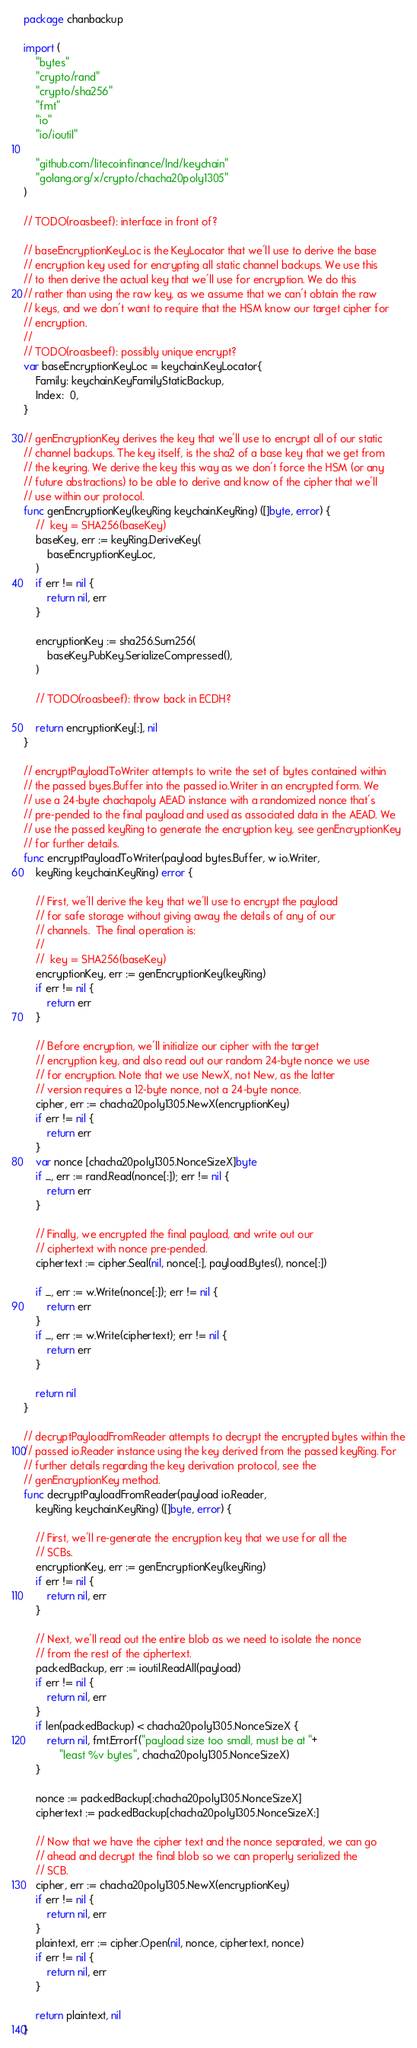<code> <loc_0><loc_0><loc_500><loc_500><_Go_>package chanbackup

import (
	"bytes"
	"crypto/rand"
	"crypto/sha256"
	"fmt"
	"io"
	"io/ioutil"

	"github.com/litecoinfinance/lnd/keychain"
	"golang.org/x/crypto/chacha20poly1305"
)

// TODO(roasbeef): interface in front of?

// baseEncryptionKeyLoc is the KeyLocator that we'll use to derive the base
// encryption key used for encrypting all static channel backups. We use this
// to then derive the actual key that we'll use for encryption. We do this
// rather than using the raw key, as we assume that we can't obtain the raw
// keys, and we don't want to require that the HSM know our target cipher for
// encryption.
//
// TODO(roasbeef): possibly unique encrypt?
var baseEncryptionKeyLoc = keychain.KeyLocator{
	Family: keychain.KeyFamilyStaticBackup,
	Index:  0,
}

// genEncryptionKey derives the key that we'll use to encrypt all of our static
// channel backups. The key itself, is the sha2 of a base key that we get from
// the keyring. We derive the key this way as we don't force the HSM (or any
// future abstractions) to be able to derive and know of the cipher that we'll
// use within our protocol.
func genEncryptionKey(keyRing keychain.KeyRing) ([]byte, error) {
	//  key = SHA256(baseKey)
	baseKey, err := keyRing.DeriveKey(
		baseEncryptionKeyLoc,
	)
	if err != nil {
		return nil, err
	}

	encryptionKey := sha256.Sum256(
		baseKey.PubKey.SerializeCompressed(),
	)

	// TODO(roasbeef): throw back in ECDH?

	return encryptionKey[:], nil
}

// encryptPayloadToWriter attempts to write the set of bytes contained within
// the passed byes.Buffer into the passed io.Writer in an encrypted form. We
// use a 24-byte chachapoly AEAD instance with a randomized nonce that's
// pre-pended to the final payload and used as associated data in the AEAD. We
// use the passed keyRing to generate the encryption key, see genEncryptionKey
// for further details.
func encryptPayloadToWriter(payload bytes.Buffer, w io.Writer,
	keyRing keychain.KeyRing) error {

	// First, we'll derive the key that we'll use to encrypt the payload
	// for safe storage without giving away the details of any of our
	// channels.  The final operation is:
	//
	//  key = SHA256(baseKey)
	encryptionKey, err := genEncryptionKey(keyRing)
	if err != nil {
		return err
	}

	// Before encryption, we'll initialize our cipher with the target
	// encryption key, and also read out our random 24-byte nonce we use
	// for encryption. Note that we use NewX, not New, as the latter
	// version requires a 12-byte nonce, not a 24-byte nonce.
	cipher, err := chacha20poly1305.NewX(encryptionKey)
	if err != nil {
		return err
	}
	var nonce [chacha20poly1305.NonceSizeX]byte
	if _, err := rand.Read(nonce[:]); err != nil {
		return err
	}

	// Finally, we encrypted the final payload, and write out our
	// ciphertext with nonce pre-pended.
	ciphertext := cipher.Seal(nil, nonce[:], payload.Bytes(), nonce[:])

	if _, err := w.Write(nonce[:]); err != nil {
		return err
	}
	if _, err := w.Write(ciphertext); err != nil {
		return err
	}

	return nil
}

// decryptPayloadFromReader attempts to decrypt the encrypted bytes within the
// passed io.Reader instance using the key derived from the passed keyRing. For
// further details regarding the key derivation protocol, see the
// genEncryptionKey method.
func decryptPayloadFromReader(payload io.Reader,
	keyRing keychain.KeyRing) ([]byte, error) {

	// First, we'll re-generate the encryption key that we use for all the
	// SCBs.
	encryptionKey, err := genEncryptionKey(keyRing)
	if err != nil {
		return nil, err
	}

	// Next, we'll read out the entire blob as we need to isolate the nonce
	// from the rest of the ciphertext.
	packedBackup, err := ioutil.ReadAll(payload)
	if err != nil {
		return nil, err
	}
	if len(packedBackup) < chacha20poly1305.NonceSizeX {
		return nil, fmt.Errorf("payload size too small, must be at "+
			"least %v bytes", chacha20poly1305.NonceSizeX)
	}

	nonce := packedBackup[:chacha20poly1305.NonceSizeX]
	ciphertext := packedBackup[chacha20poly1305.NonceSizeX:]

	// Now that we have the cipher text and the nonce separated, we can go
	// ahead and decrypt the final blob so we can properly serialized the
	// SCB.
	cipher, err := chacha20poly1305.NewX(encryptionKey)
	if err != nil {
		return nil, err
	}
	plaintext, err := cipher.Open(nil, nonce, ciphertext, nonce)
	if err != nil {
		return nil, err
	}

	return plaintext, nil
}
</code> 